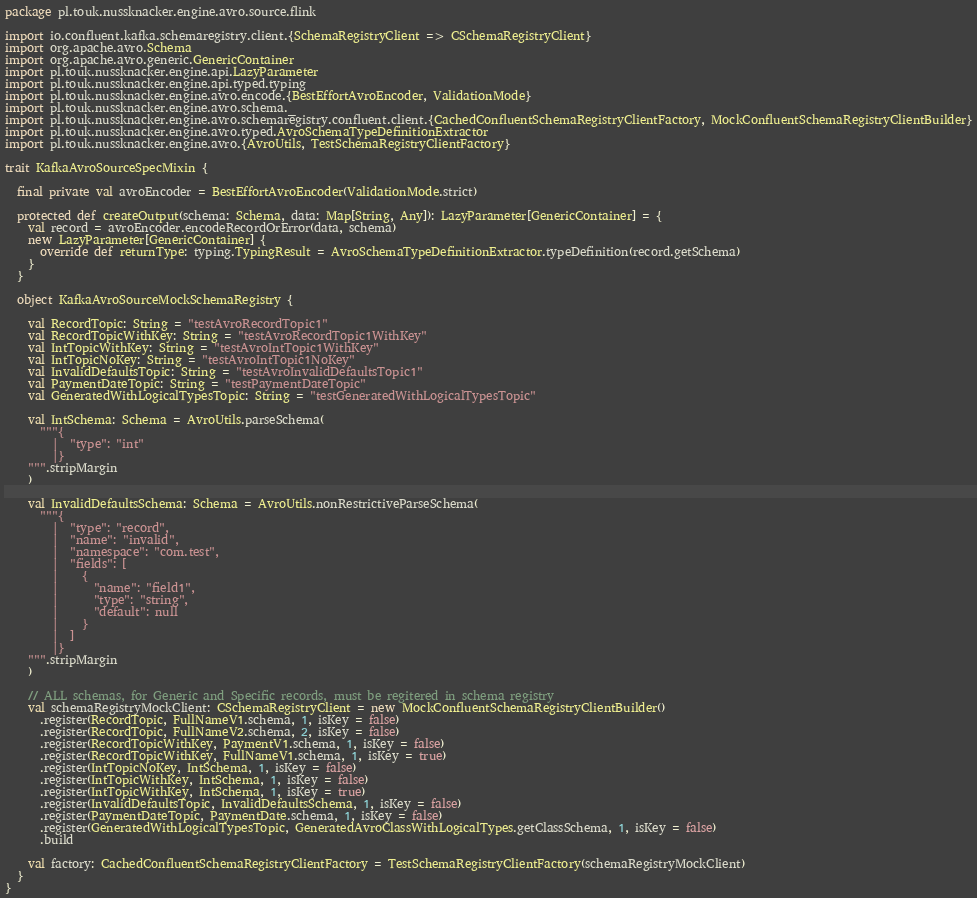<code> <loc_0><loc_0><loc_500><loc_500><_Scala_>package pl.touk.nussknacker.engine.avro.source.flink

import io.confluent.kafka.schemaregistry.client.{SchemaRegistryClient => CSchemaRegistryClient}
import org.apache.avro.Schema
import org.apache.avro.generic.GenericContainer
import pl.touk.nussknacker.engine.api.LazyParameter
import pl.touk.nussknacker.engine.api.typed.typing
import pl.touk.nussknacker.engine.avro.encode.{BestEffortAvroEncoder, ValidationMode}
import pl.touk.nussknacker.engine.avro.schema._
import pl.touk.nussknacker.engine.avro.schemaregistry.confluent.client.{CachedConfluentSchemaRegistryClientFactory, MockConfluentSchemaRegistryClientBuilder}
import pl.touk.nussknacker.engine.avro.typed.AvroSchemaTypeDefinitionExtractor
import pl.touk.nussknacker.engine.avro.{AvroUtils, TestSchemaRegistryClientFactory}

trait KafkaAvroSourceSpecMixin {

  final private val avroEncoder = BestEffortAvroEncoder(ValidationMode.strict)

  protected def createOutput(schema: Schema, data: Map[String, Any]): LazyParameter[GenericContainer] = {
    val record = avroEncoder.encodeRecordOrError(data, schema)
    new LazyParameter[GenericContainer] {
      override def returnType: typing.TypingResult = AvroSchemaTypeDefinitionExtractor.typeDefinition(record.getSchema)
    }
  }

  object KafkaAvroSourceMockSchemaRegistry {

    val RecordTopic: String = "testAvroRecordTopic1"
    val RecordTopicWithKey: String = "testAvroRecordTopic1WithKey"
    val IntTopicWithKey: String = "testAvroIntTopic1WithKey"
    val IntTopicNoKey: String = "testAvroIntTopic1NoKey"
    val InvalidDefaultsTopic: String = "testAvroInvalidDefaultsTopic1"
    val PaymentDateTopic: String = "testPaymentDateTopic"
    val GeneratedWithLogicalTypesTopic: String = "testGeneratedWithLogicalTypesTopic"

    val IntSchema: Schema = AvroUtils.parseSchema(
      """{
        |  "type": "int"
        |}
    """.stripMargin
    )

    val InvalidDefaultsSchema: Schema = AvroUtils.nonRestrictiveParseSchema(
      """{
        |  "type": "record",
        |  "name": "invalid",
        |  "namespace": "com.test",
        |  "fields": [
        |    {
        |      "name": "field1",
        |      "type": "string",
        |      "default": null
        |    }
        |  ]
        |}
    """.stripMargin
    )

    // ALL schemas, for Generic and Specific records, must be regitered in schema registry
    val schemaRegistryMockClient: CSchemaRegistryClient = new MockConfluentSchemaRegistryClientBuilder()
      .register(RecordTopic, FullNameV1.schema, 1, isKey = false)
      .register(RecordTopic, FullNameV2.schema, 2, isKey = false)
      .register(RecordTopicWithKey, PaymentV1.schema, 1, isKey = false)
      .register(RecordTopicWithKey, FullNameV1.schema, 1, isKey = true)
      .register(IntTopicNoKey, IntSchema, 1, isKey = false)
      .register(IntTopicWithKey, IntSchema, 1, isKey = false)
      .register(IntTopicWithKey, IntSchema, 1, isKey = true)
      .register(InvalidDefaultsTopic, InvalidDefaultsSchema, 1, isKey = false)
      .register(PaymentDateTopic, PaymentDate.schema, 1, isKey = false)
      .register(GeneratedWithLogicalTypesTopic, GeneratedAvroClassWithLogicalTypes.getClassSchema, 1, isKey = false)
      .build

    val factory: CachedConfluentSchemaRegistryClientFactory = TestSchemaRegistryClientFactory(schemaRegistryMockClient)
  }
}
</code> 